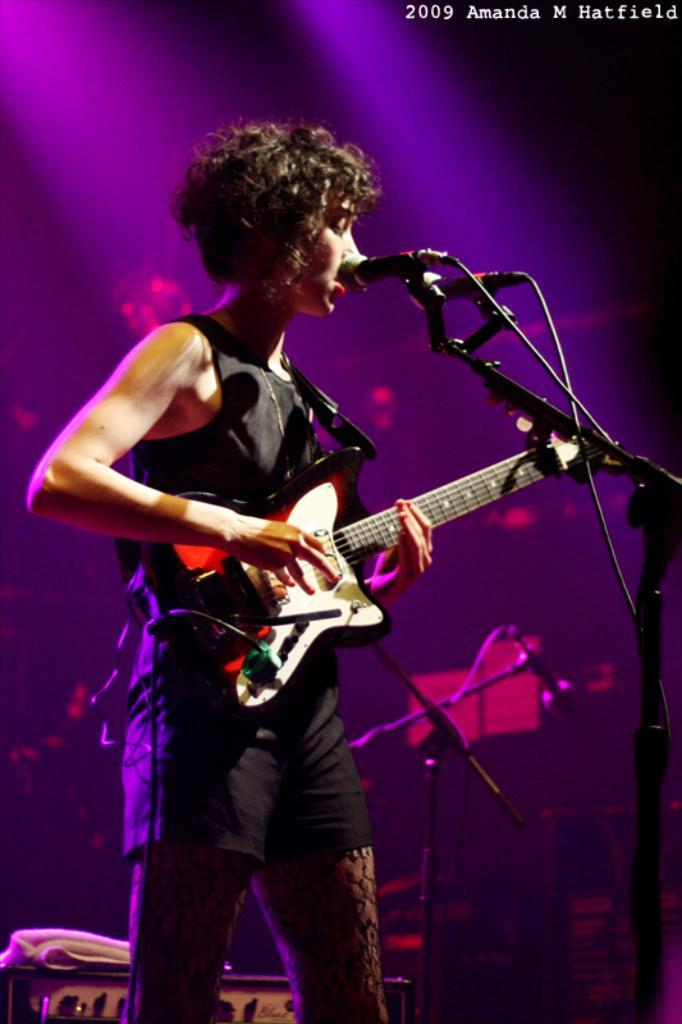What is the person in the image doing? The person is standing and playing a guitar. What is the person wearing in the image? The person is wearing a black dress. What object is present for amplifying the person's voice? There is a microphone in the image. What can be seen in the background of the image? There are other objects in the background of the image. How many planes are flying in the background of the image? There are no planes visible in the image. What type of bag is the person holding while playing the guitar? The person is not holding a bag in the image. 